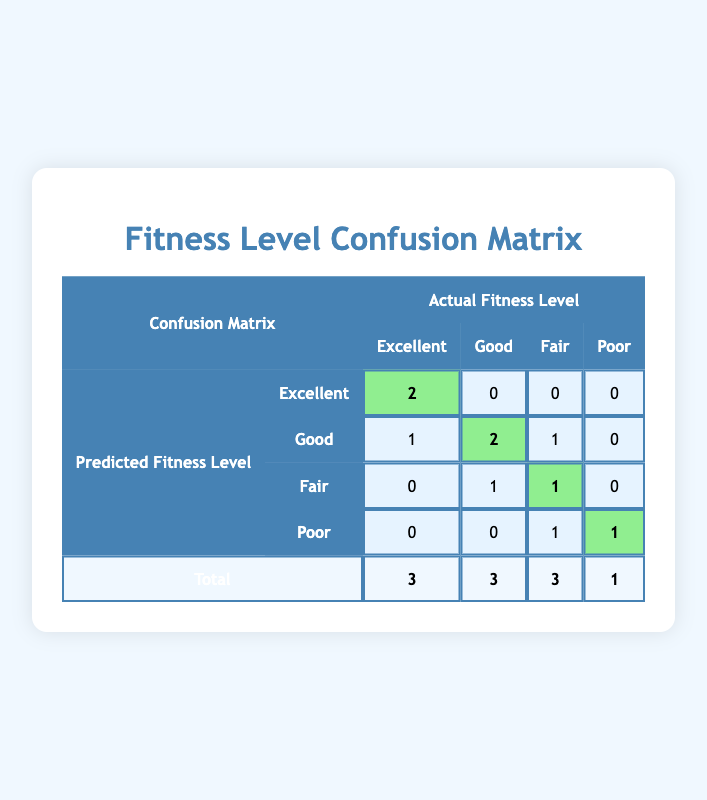What is the number of students predicted to have an 'Excellent' fitness level? In the confusion matrix, the row for 'Excellent' under the predicted fitness level has a value of 2 in the 'Excellent' actual fitness level column. Hence, the number of students predicted to have an 'Excellent' fitness level is 2.
Answer: 2 How many students were predicted to have a 'Good' fitness level? Under the 'Good' category for predicted fitness level, there are three values: 1 (predicted as 'Excellent' with actual 'Good'), 2 (predicted as 'Good' with actual 'Good'), and 1 (predicted as 'Fair' with actual 'Good'). Adding these, 1 + 2 + 1 = 4 students were predicted as 'Good'.
Answer: 4 What is the total number of students classified as 'Poor'? To find the number of students classified as 'Poor', we check the last row where the predicted fitness level is 'Poor'. The corresponding actual fitness level column has a value of 1 for 'Poor'. Thus, there is 1 student classified as 'Poor'.
Answer: 1 Is it true that more students were accurately predicted as 'Good' than as 'Fair'? Comparing the values for 'Good' and 'Fair', there are 2 students accurately predicted as 'Good' and 1 student as 'Fair'. Therefore, it is true that more students were accurately predicted as 'Good'.
Answer: Yes What is the total number of 'Fair' predictions compared to 'Excellent' predictions? The total for 'Fair' predictions comes from the row for 'Fair', where 1 student is predicted as 'Fair' and 1 student is predicted as 'Good' with an actual 'Fair', giving a sum of 1 for 'Fair'. On the other hand, the total 'Excellent' predictions from the corresponding row is 2. Therefore, the total for 'Fair' is 2 while 'Excellent' is 1. The comparison shows 2 (Fair) is greater than 1 (Excellent).
Answer: Fair has 2, Excellent has 2; Fair is greater than Excellent How many students were inaccurately predicted as 'Good'? Reviewing the 'Good' predicted level, we see 1 (predicted 'Good', actual 'Fair') plus 0 (predicted 'Good', actual 'Excellent') makes it 1 inaccurate prediction. Therefore, the number of students incorrectly predicted as 'Good' fitness level is 1.
Answer: 1 What is the average correct prediction across all fitness levels? First, we sum the correct predictions: 2 (Excellent) + 2 (Good) + 1 (Fair) + 1 (Poor) gives a total of 6 correct predictions. Next, to find the average, we divide by the number of categories (4): 6/4 = 1.5. Hence, the average correct prediction is 1.5.
Answer: 1.5 How do predictions for 'Poor' compare with predictions for 'Excellent'? Under the 'Poor' predicted fitness level row, the actual counts are 1 (Poor) with 0 in other categories, giving a total of 1 student. Meanwhile, for 'Excellent', there are 2 predicted accurately. Thus, predictions for 'Excellent' (2) are greater than for 'Poor' (1).
Answer: Excellent predictions are greater 